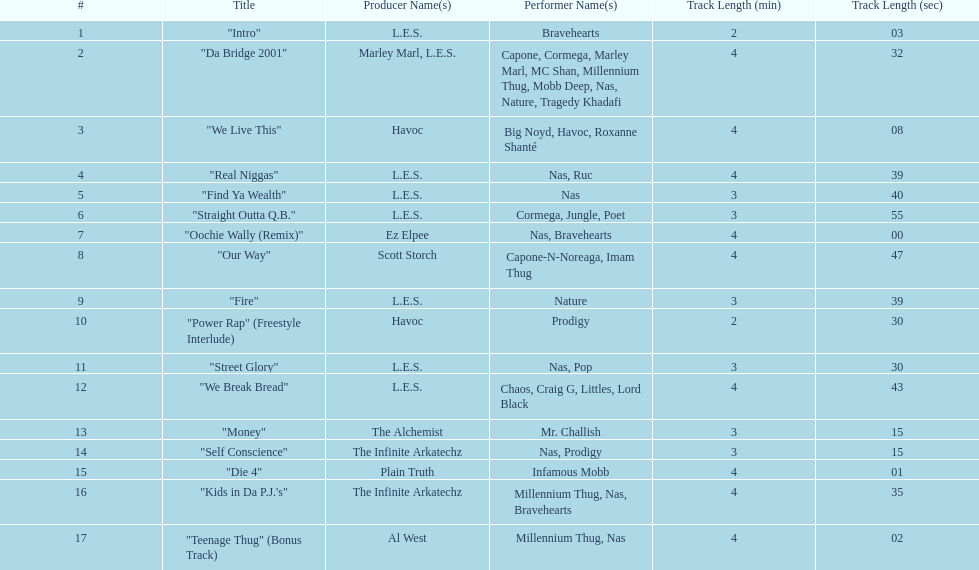How many songs are at least 4 minutes long? 9. Can you parse all the data within this table? {'header': ['#', 'Title', 'Producer Name(s)', 'Performer Name(s)', 'Track Length (min)', 'Track Length (sec)'], 'rows': [['1', '"Intro"', 'L.E.S.', 'Bravehearts', '2', '03'], ['2', '"Da Bridge 2001"', 'Marley Marl, L.E.S.', 'Capone, Cormega, Marley Marl, MC Shan, Millennium Thug, Mobb Deep, Nas, Nature, Tragedy Khadafi', '4', '32'], ['3', '"We Live This"', 'Havoc', 'Big Noyd, Havoc, Roxanne Shanté', '4', '08'], ['4', '"Real Niggas"', 'L.E.S.', 'Nas, Ruc', '4', '39'], ['5', '"Find Ya Wealth"', 'L.E.S.', 'Nas', '3', '40'], ['6', '"Straight Outta Q.B."', 'L.E.S.', 'Cormega, Jungle, Poet', '3', '55'], ['7', '"Oochie Wally (Remix)"', 'Ez Elpee', 'Nas, Bravehearts', '4', '00'], ['8', '"Our Way"', 'Scott Storch', 'Capone-N-Noreaga, Imam Thug', '4', '47'], ['9', '"Fire"', 'L.E.S.', 'Nature', '3', '39'], ['10', '"Power Rap" (Freestyle Interlude)', 'Havoc', 'Prodigy', '2', '30'], ['11', '"Street Glory"', 'L.E.S.', 'Nas, Pop', '3', '30'], ['12', '"We Break Bread"', 'L.E.S.', 'Chaos, Craig G, Littles, Lord Black', '4', '43'], ['13', '"Money"', 'The Alchemist', 'Mr. Challish', '3', '15'], ['14', '"Self Conscience"', 'The Infinite Arkatechz', 'Nas, Prodigy', '3', '15'], ['15', '"Die 4"', 'Plain Truth', 'Infamous Mobb', '4', '01'], ['16', '"Kids in Da P.J.\'s"', 'The Infinite Arkatechz', 'Millennium Thug, Nas, Bravehearts', '4', '35'], ['17', '"Teenage Thug" (Bonus Track)', 'Al West', 'Millennium Thug, Nas', '4', '02']]} 